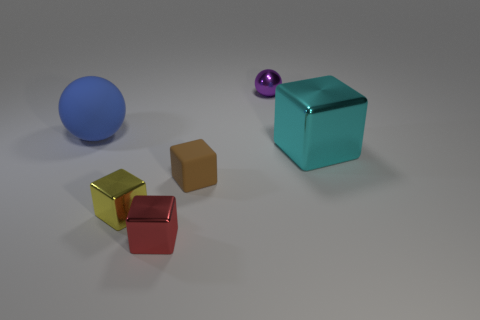How does the lighting in the image influence the perception of the objects? The lighting in the image is soft and diffused, creating gentle shadows and only subtle reflections on the surfaces of the objects. This lighting setup enhances the perception of the different textures and materials of the objects. It gives a sense of depth and dimensionality to the scene while also highlighting the unique characteristics of each object, such as the shine on the reflective surfaces and the more absorbent quality of the matte finishes. 